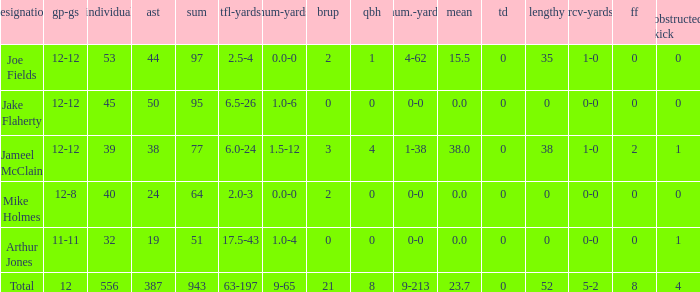What is the total brup for the team? 21.0. 